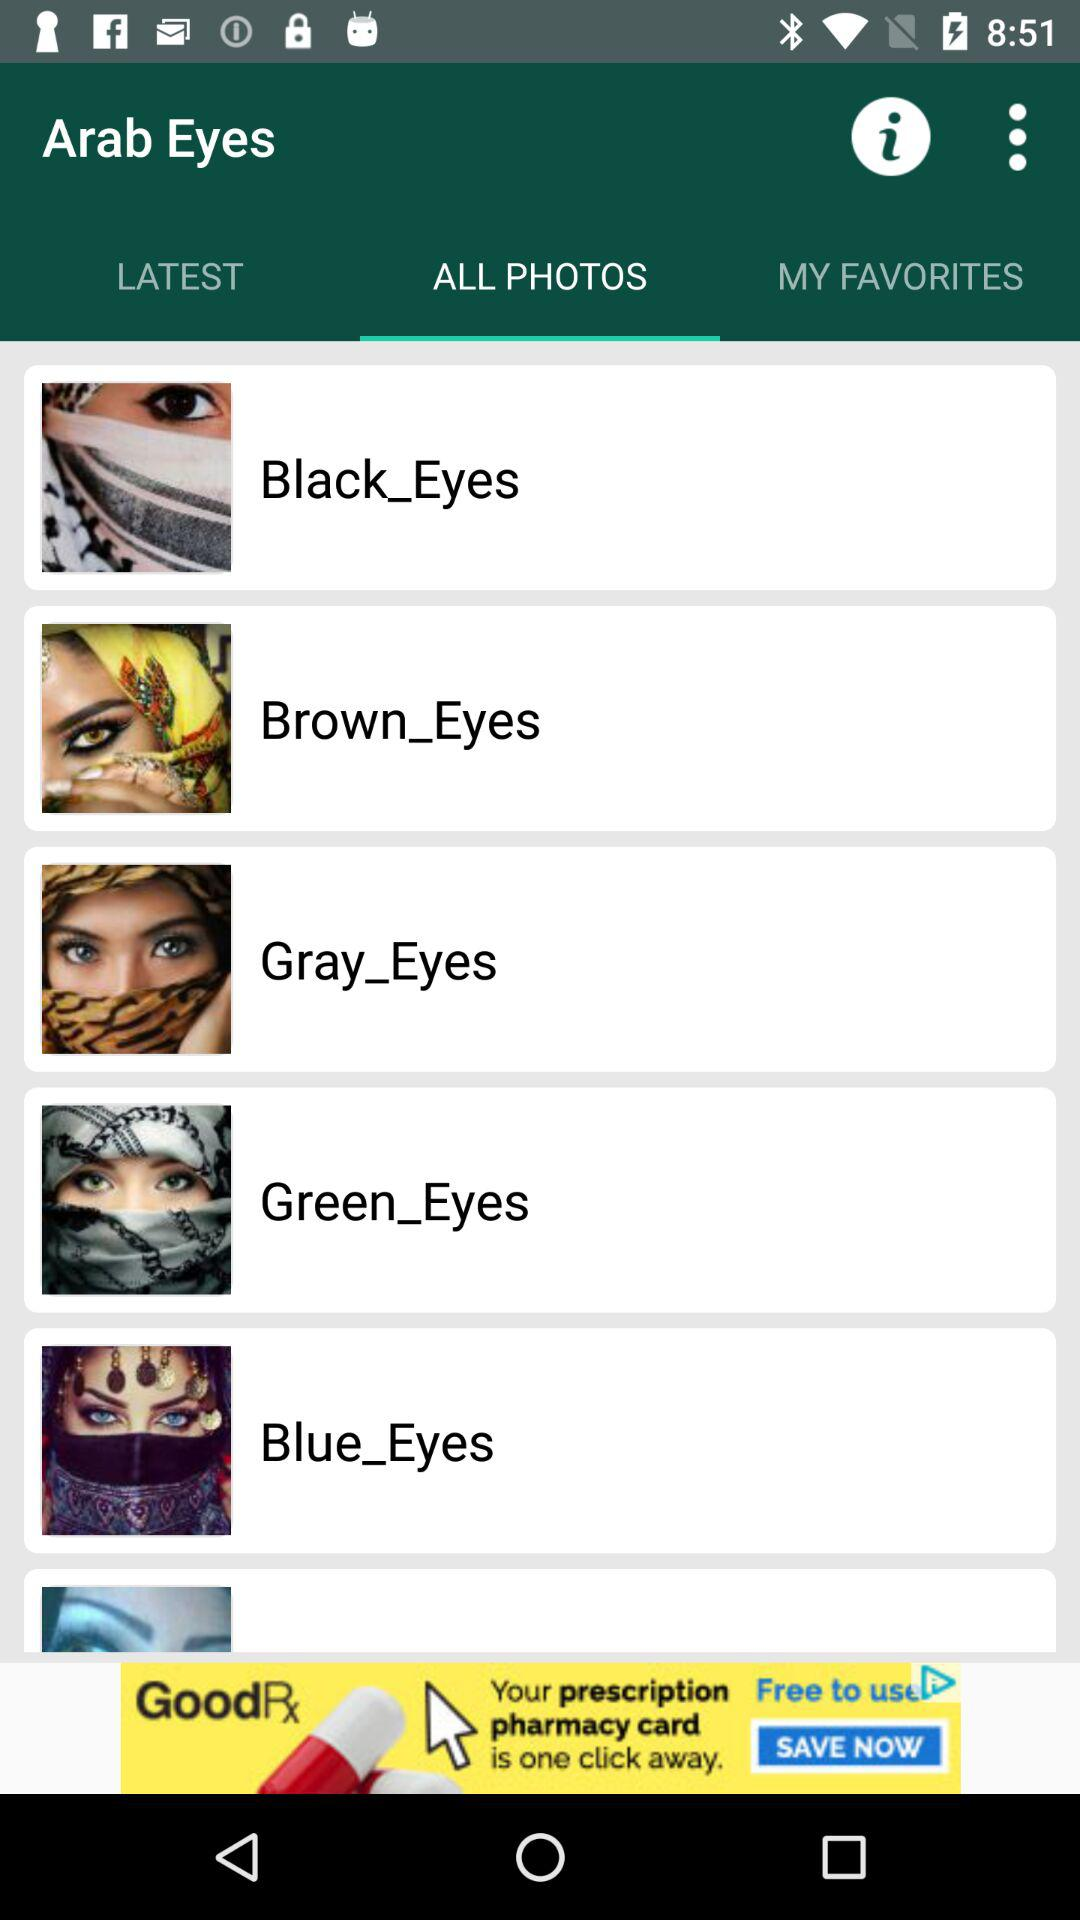What are the available options in "ALL PHOTOS"? The available options in "ALL PHOTOS" are "Black_Eyes", "Brown_Eyes", "Gray_Eyes", "Green_Eyes" and "Blue_Eyes". 